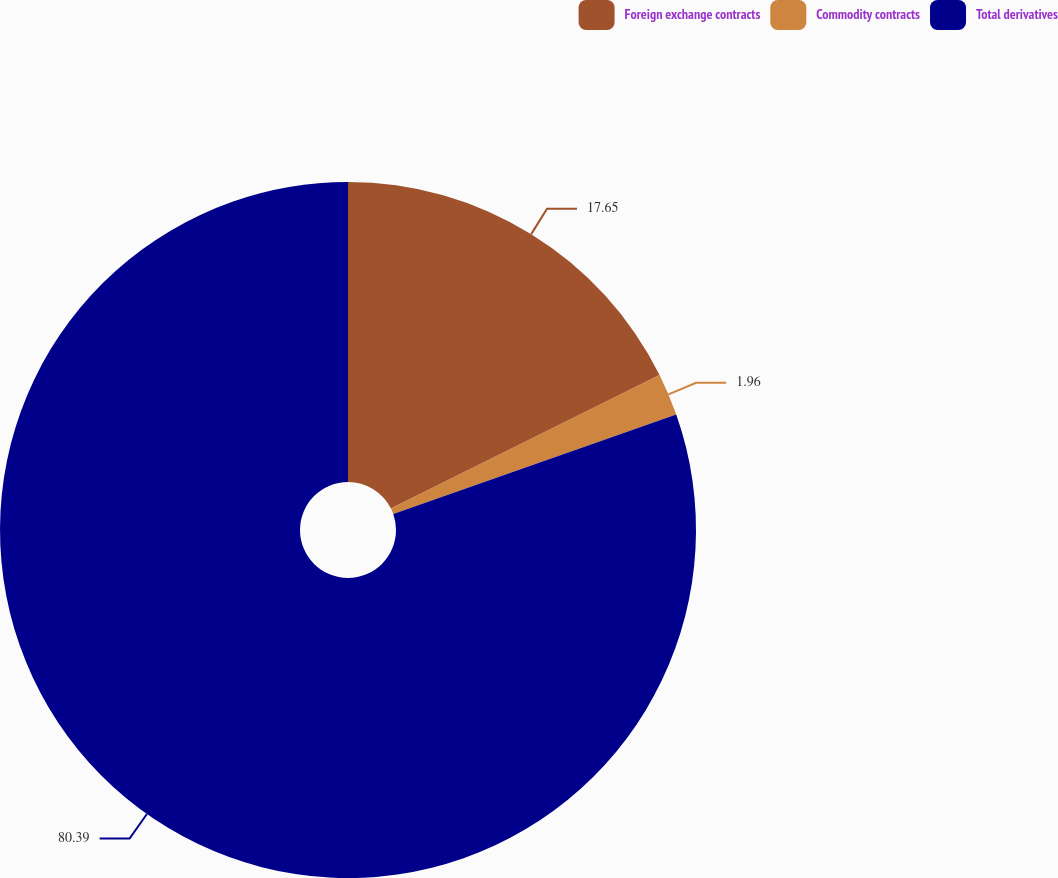<chart> <loc_0><loc_0><loc_500><loc_500><pie_chart><fcel>Foreign exchange contracts<fcel>Commodity contracts<fcel>Total derivatives<nl><fcel>17.65%<fcel>1.96%<fcel>80.39%<nl></chart> 